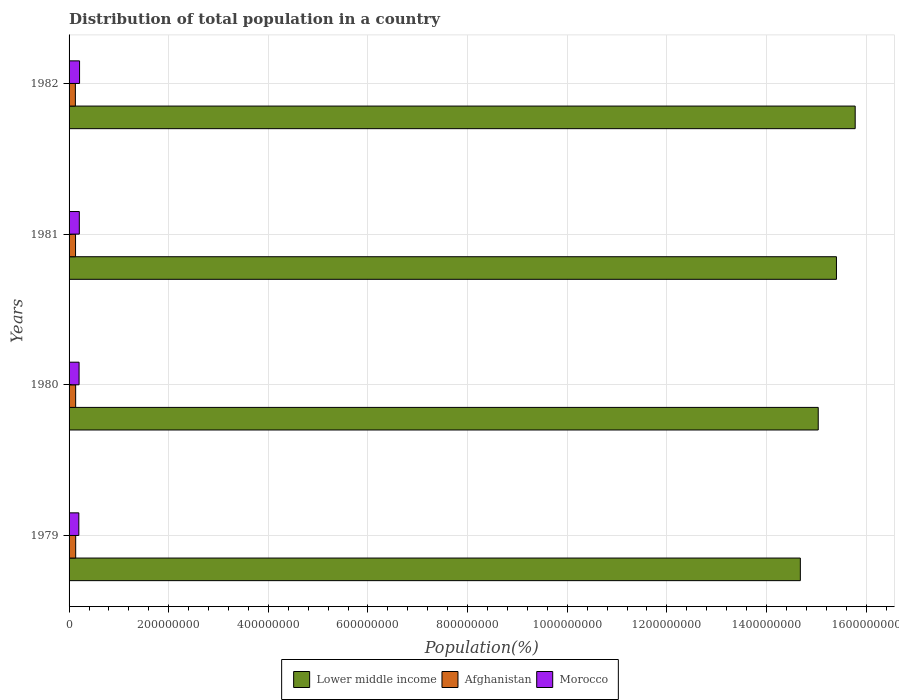How many different coloured bars are there?
Offer a terse response. 3. Are the number of bars per tick equal to the number of legend labels?
Keep it short and to the point. Yes. Are the number of bars on each tick of the Y-axis equal?
Your answer should be compact. Yes. In how many cases, is the number of bars for a given year not equal to the number of legend labels?
Keep it short and to the point. 0. What is the population of in Lower middle income in 1981?
Your answer should be very brief. 1.54e+09. Across all years, what is the maximum population of in Afghanistan?
Provide a short and direct response. 1.33e+07. Across all years, what is the minimum population of in Lower middle income?
Make the answer very short. 1.47e+09. In which year was the population of in Lower middle income minimum?
Ensure brevity in your answer.  1979. What is the total population of in Afghanistan in the graph?
Provide a short and direct response. 5.22e+07. What is the difference between the population of in Lower middle income in 1979 and that in 1981?
Your response must be concise. -7.25e+07. What is the difference between the population of in Afghanistan in 1981 and the population of in Lower middle income in 1979?
Provide a short and direct response. -1.45e+09. What is the average population of in Afghanistan per year?
Your answer should be very brief. 1.30e+07. In the year 1982, what is the difference between the population of in Lower middle income and population of in Afghanistan?
Give a very brief answer. 1.57e+09. What is the ratio of the population of in Morocco in 1979 to that in 1981?
Offer a very short reply. 0.95. Is the population of in Lower middle income in 1979 less than that in 1982?
Offer a very short reply. Yes. What is the difference between the highest and the second highest population of in Morocco?
Your answer should be very brief. 5.06e+05. What is the difference between the highest and the lowest population of in Lower middle income?
Keep it short and to the point. 1.10e+08. In how many years, is the population of in Lower middle income greater than the average population of in Lower middle income taken over all years?
Offer a terse response. 2. Is the sum of the population of in Morocco in 1981 and 1982 greater than the maximum population of in Lower middle income across all years?
Offer a terse response. No. What does the 1st bar from the top in 1982 represents?
Your answer should be very brief. Morocco. What does the 1st bar from the bottom in 1982 represents?
Provide a succinct answer. Lower middle income. Are all the bars in the graph horizontal?
Offer a terse response. Yes. Does the graph contain any zero values?
Make the answer very short. No. Does the graph contain grids?
Your response must be concise. Yes. Where does the legend appear in the graph?
Keep it short and to the point. Bottom center. How are the legend labels stacked?
Your answer should be very brief. Horizontal. What is the title of the graph?
Offer a terse response. Distribution of total population in a country. What is the label or title of the X-axis?
Offer a very short reply. Population(%). What is the Population(%) in Lower middle income in 1979?
Ensure brevity in your answer.  1.47e+09. What is the Population(%) in Afghanistan in 1979?
Your answer should be compact. 1.33e+07. What is the Population(%) in Morocco in 1979?
Offer a terse response. 1.96e+07. What is the Population(%) in Lower middle income in 1980?
Provide a succinct answer. 1.50e+09. What is the Population(%) in Afghanistan in 1980?
Keep it short and to the point. 1.32e+07. What is the Population(%) of Morocco in 1980?
Provide a succinct answer. 2.01e+07. What is the Population(%) of Lower middle income in 1981?
Provide a short and direct response. 1.54e+09. What is the Population(%) in Afghanistan in 1981?
Give a very brief answer. 1.30e+07. What is the Population(%) of Morocco in 1981?
Offer a terse response. 2.06e+07. What is the Population(%) of Lower middle income in 1982?
Give a very brief answer. 1.58e+09. What is the Population(%) of Afghanistan in 1982?
Provide a succinct answer. 1.27e+07. What is the Population(%) in Morocco in 1982?
Ensure brevity in your answer.  2.11e+07. Across all years, what is the maximum Population(%) of Lower middle income?
Make the answer very short. 1.58e+09. Across all years, what is the maximum Population(%) in Afghanistan?
Offer a terse response. 1.33e+07. Across all years, what is the maximum Population(%) of Morocco?
Your response must be concise. 2.11e+07. Across all years, what is the minimum Population(%) in Lower middle income?
Keep it short and to the point. 1.47e+09. Across all years, what is the minimum Population(%) in Afghanistan?
Your answer should be very brief. 1.27e+07. Across all years, what is the minimum Population(%) in Morocco?
Provide a succinct answer. 1.96e+07. What is the total Population(%) of Lower middle income in the graph?
Your answer should be very brief. 6.09e+09. What is the total Population(%) of Afghanistan in the graph?
Give a very brief answer. 5.22e+07. What is the total Population(%) in Morocco in the graph?
Give a very brief answer. 8.13e+07. What is the difference between the Population(%) of Lower middle income in 1979 and that in 1980?
Give a very brief answer. -3.59e+07. What is the difference between the Population(%) of Afghanistan in 1979 and that in 1980?
Keep it short and to the point. 7.19e+04. What is the difference between the Population(%) of Morocco in 1979 and that in 1980?
Offer a very short reply. -4.77e+05. What is the difference between the Population(%) in Lower middle income in 1979 and that in 1981?
Your answer should be compact. -7.25e+07. What is the difference between the Population(%) in Afghanistan in 1979 and that in 1981?
Your response must be concise. 2.86e+05. What is the difference between the Population(%) of Morocco in 1979 and that in 1981?
Your response must be concise. -9.69e+05. What is the difference between the Population(%) of Lower middle income in 1979 and that in 1982?
Ensure brevity in your answer.  -1.10e+08. What is the difference between the Population(%) of Afghanistan in 1979 and that in 1982?
Ensure brevity in your answer.  6.16e+05. What is the difference between the Population(%) of Morocco in 1979 and that in 1982?
Provide a succinct answer. -1.48e+06. What is the difference between the Population(%) of Lower middle income in 1980 and that in 1981?
Provide a succinct answer. -3.66e+07. What is the difference between the Population(%) of Afghanistan in 1980 and that in 1981?
Keep it short and to the point. 2.14e+05. What is the difference between the Population(%) of Morocco in 1980 and that in 1981?
Offer a very short reply. -4.92e+05. What is the difference between the Population(%) of Lower middle income in 1980 and that in 1982?
Ensure brevity in your answer.  -7.42e+07. What is the difference between the Population(%) of Afghanistan in 1980 and that in 1982?
Ensure brevity in your answer.  5.44e+05. What is the difference between the Population(%) of Morocco in 1980 and that in 1982?
Make the answer very short. -9.99e+05. What is the difference between the Population(%) in Lower middle income in 1981 and that in 1982?
Provide a succinct answer. -3.76e+07. What is the difference between the Population(%) in Afghanistan in 1981 and that in 1982?
Your answer should be compact. 3.30e+05. What is the difference between the Population(%) in Morocco in 1981 and that in 1982?
Provide a succinct answer. -5.06e+05. What is the difference between the Population(%) of Lower middle income in 1979 and the Population(%) of Afghanistan in 1980?
Ensure brevity in your answer.  1.45e+09. What is the difference between the Population(%) in Lower middle income in 1979 and the Population(%) in Morocco in 1980?
Provide a succinct answer. 1.45e+09. What is the difference between the Population(%) of Afghanistan in 1979 and the Population(%) of Morocco in 1980?
Ensure brevity in your answer.  -6.79e+06. What is the difference between the Population(%) of Lower middle income in 1979 and the Population(%) of Afghanistan in 1981?
Offer a very short reply. 1.45e+09. What is the difference between the Population(%) of Lower middle income in 1979 and the Population(%) of Morocco in 1981?
Your response must be concise. 1.45e+09. What is the difference between the Population(%) in Afghanistan in 1979 and the Population(%) in Morocco in 1981?
Make the answer very short. -7.28e+06. What is the difference between the Population(%) of Lower middle income in 1979 and the Population(%) of Afghanistan in 1982?
Offer a terse response. 1.46e+09. What is the difference between the Population(%) in Lower middle income in 1979 and the Population(%) in Morocco in 1982?
Give a very brief answer. 1.45e+09. What is the difference between the Population(%) in Afghanistan in 1979 and the Population(%) in Morocco in 1982?
Ensure brevity in your answer.  -7.79e+06. What is the difference between the Population(%) of Lower middle income in 1980 and the Population(%) of Afghanistan in 1981?
Provide a short and direct response. 1.49e+09. What is the difference between the Population(%) of Lower middle income in 1980 and the Population(%) of Morocco in 1981?
Give a very brief answer. 1.48e+09. What is the difference between the Population(%) of Afghanistan in 1980 and the Population(%) of Morocco in 1981?
Your answer should be compact. -7.35e+06. What is the difference between the Population(%) of Lower middle income in 1980 and the Population(%) of Afghanistan in 1982?
Your answer should be very brief. 1.49e+09. What is the difference between the Population(%) of Lower middle income in 1980 and the Population(%) of Morocco in 1982?
Your answer should be compact. 1.48e+09. What is the difference between the Population(%) of Afghanistan in 1980 and the Population(%) of Morocco in 1982?
Offer a very short reply. -7.86e+06. What is the difference between the Population(%) of Lower middle income in 1981 and the Population(%) of Afghanistan in 1982?
Give a very brief answer. 1.53e+09. What is the difference between the Population(%) of Lower middle income in 1981 and the Population(%) of Morocco in 1982?
Keep it short and to the point. 1.52e+09. What is the difference between the Population(%) in Afghanistan in 1981 and the Population(%) in Morocco in 1982?
Your answer should be very brief. -8.07e+06. What is the average Population(%) of Lower middle income per year?
Give a very brief answer. 1.52e+09. What is the average Population(%) in Afghanistan per year?
Your response must be concise. 1.30e+07. What is the average Population(%) of Morocco per year?
Make the answer very short. 2.03e+07. In the year 1979, what is the difference between the Population(%) in Lower middle income and Population(%) in Afghanistan?
Your answer should be very brief. 1.45e+09. In the year 1979, what is the difference between the Population(%) in Lower middle income and Population(%) in Morocco?
Ensure brevity in your answer.  1.45e+09. In the year 1979, what is the difference between the Population(%) of Afghanistan and Population(%) of Morocco?
Give a very brief answer. -6.31e+06. In the year 1980, what is the difference between the Population(%) of Lower middle income and Population(%) of Afghanistan?
Make the answer very short. 1.49e+09. In the year 1980, what is the difference between the Population(%) of Lower middle income and Population(%) of Morocco?
Your response must be concise. 1.48e+09. In the year 1980, what is the difference between the Population(%) in Afghanistan and Population(%) in Morocco?
Your answer should be very brief. -6.86e+06. In the year 1981, what is the difference between the Population(%) in Lower middle income and Population(%) in Afghanistan?
Give a very brief answer. 1.53e+09. In the year 1981, what is the difference between the Population(%) in Lower middle income and Population(%) in Morocco?
Keep it short and to the point. 1.52e+09. In the year 1981, what is the difference between the Population(%) in Afghanistan and Population(%) in Morocco?
Provide a short and direct response. -7.57e+06. In the year 1982, what is the difference between the Population(%) of Lower middle income and Population(%) of Afghanistan?
Make the answer very short. 1.57e+09. In the year 1982, what is the difference between the Population(%) in Lower middle income and Population(%) in Morocco?
Make the answer very short. 1.56e+09. In the year 1982, what is the difference between the Population(%) of Afghanistan and Population(%) of Morocco?
Ensure brevity in your answer.  -8.40e+06. What is the ratio of the Population(%) in Lower middle income in 1979 to that in 1980?
Keep it short and to the point. 0.98. What is the ratio of the Population(%) of Afghanistan in 1979 to that in 1980?
Offer a very short reply. 1.01. What is the ratio of the Population(%) of Morocco in 1979 to that in 1980?
Offer a very short reply. 0.98. What is the ratio of the Population(%) of Lower middle income in 1979 to that in 1981?
Your answer should be very brief. 0.95. What is the ratio of the Population(%) in Afghanistan in 1979 to that in 1981?
Offer a very short reply. 1.02. What is the ratio of the Population(%) of Morocco in 1979 to that in 1981?
Your answer should be compact. 0.95. What is the ratio of the Population(%) of Lower middle income in 1979 to that in 1982?
Give a very brief answer. 0.93. What is the ratio of the Population(%) of Afghanistan in 1979 to that in 1982?
Ensure brevity in your answer.  1.05. What is the ratio of the Population(%) in Lower middle income in 1980 to that in 1981?
Offer a very short reply. 0.98. What is the ratio of the Population(%) in Afghanistan in 1980 to that in 1981?
Keep it short and to the point. 1.02. What is the ratio of the Population(%) of Morocco in 1980 to that in 1981?
Your response must be concise. 0.98. What is the ratio of the Population(%) of Lower middle income in 1980 to that in 1982?
Provide a succinct answer. 0.95. What is the ratio of the Population(%) in Afghanistan in 1980 to that in 1982?
Ensure brevity in your answer.  1.04. What is the ratio of the Population(%) of Morocco in 1980 to that in 1982?
Keep it short and to the point. 0.95. What is the ratio of the Population(%) in Lower middle income in 1981 to that in 1982?
Give a very brief answer. 0.98. What is the ratio of the Population(%) in Morocco in 1981 to that in 1982?
Offer a terse response. 0.98. What is the difference between the highest and the second highest Population(%) of Lower middle income?
Provide a succinct answer. 3.76e+07. What is the difference between the highest and the second highest Population(%) in Afghanistan?
Make the answer very short. 7.19e+04. What is the difference between the highest and the second highest Population(%) of Morocco?
Provide a short and direct response. 5.06e+05. What is the difference between the highest and the lowest Population(%) in Lower middle income?
Keep it short and to the point. 1.10e+08. What is the difference between the highest and the lowest Population(%) in Afghanistan?
Your response must be concise. 6.16e+05. What is the difference between the highest and the lowest Population(%) of Morocco?
Ensure brevity in your answer.  1.48e+06. 